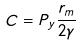Convert formula to latex. <formula><loc_0><loc_0><loc_500><loc_500>C = P _ { y } \frac { r _ { m } } { 2 \gamma }</formula> 